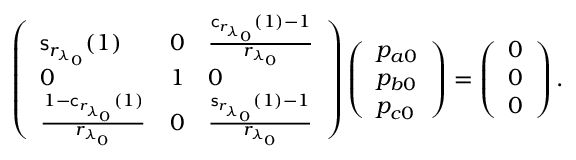<formula> <loc_0><loc_0><loc_500><loc_500>\left ( \begin{array} { l l l } { s _ { r _ { \lambda _ { 0 } } } ( 1 ) } & { 0 } & { \frac { c _ { r _ { \lambda _ { 0 } } } ( 1 ) - 1 } { { r _ { \lambda _ { 0 } } } } } \\ { 0 } & { 1 } & { 0 } \\ { \frac { 1 - c _ { r _ { \lambda _ { 0 } } } ( 1 ) } { { r _ { \lambda _ { 0 } } } } } & { 0 } & { \frac { s _ { r _ { \lambda _ { 0 } } } ( 1 ) - 1 } { { r _ { \lambda _ { 0 } } } } } \end{array} \right ) \left ( \begin{array} { l } { p _ { a 0 } } \\ { p _ { b 0 } } \\ { p _ { c 0 } } \end{array} \right ) = \left ( \begin{array} { l } { 0 } \\ { 0 } \\ { 0 } \end{array} \right ) .</formula> 